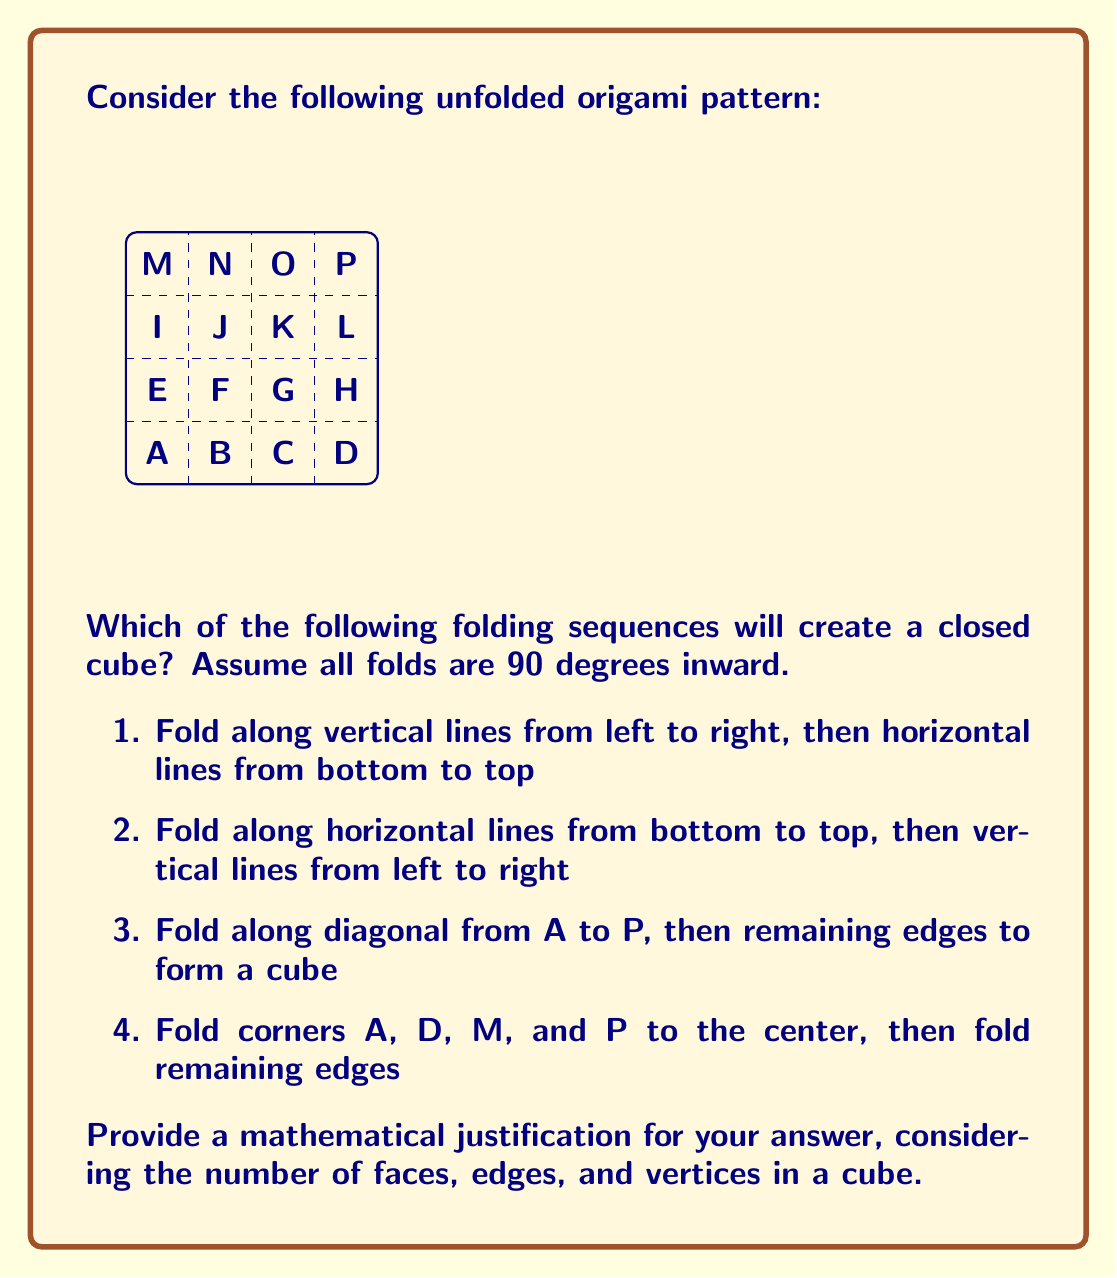Show me your answer to this math problem. To solve this problem, we need to consider the properties of a cube and how they relate to the given origami pattern:

1. A cube has 6 faces, 12 edges, and 8 vertices.
2. Each face of the cube must be a square.
3. The unfolded pattern must contain all 6 faces without overlap.

Let's analyze each folding sequence:

1. Folding vertical lines then horizontal lines:
   - This creates a long rectangular prism with dimensions 1x1x4.
   - It does not form a cube.

2. Folding horizontal lines then vertical lines:
   - This creates a tall rectangular prism with dimensions 1x4x1.
   - It does not form a cube.

3. Folding along diagonal A to P:
   - This does not create a valid folding pattern for a cube.
   - It would result in triangular faces, which are not present in a cube.

4. Folding corners to center, then remaining edges:
   - This is the correct folding sequence.

Let's verify the fourth option mathematically:

a) Folding corners A, D, M, and P to the center creates four triangular flaps.
b) The remaining central cross forms the four side faces of the cube.
c) The triangular flaps fold up to create the top and bottom faces.

Counting the faces:
- 4 side faces from the central cross
- 1 top face and 1 bottom face from the triangular flaps
Total: 6 faces

Counting the edges:
- 4 vertical edges from the sides of the central cross
- 4 top edges and 4 bottom edges from the folded triangular flaps
Total: 12 edges

Counting the vertices:
- 4 vertices from the corners of the central cross
- 4 vertices from the points of the folded triangular flaps
Total: 8 vertices

These counts match the properties of a cube: 6 faces, 12 edges, and 8 vertices.

The surface area of the unfolded pattern is $16$ square units (4x4 square). The surface area of a cube is given by the formula $6a^2$, where $a$ is the length of an edge. Setting these equal:

$$ 16 = 6a^2 $$
$$ a^2 = \frac{16}{6} $$
$$ a = \sqrt{\frac{16}{6}} \approx 1.63 $$

This confirms that the unfolded pattern can indeed form a cube with edge length $\sqrt{\frac{16}{6}}$ units.
Answer: Option 4: Fold corners A, D, M, and P to the center, then fold remaining edges 